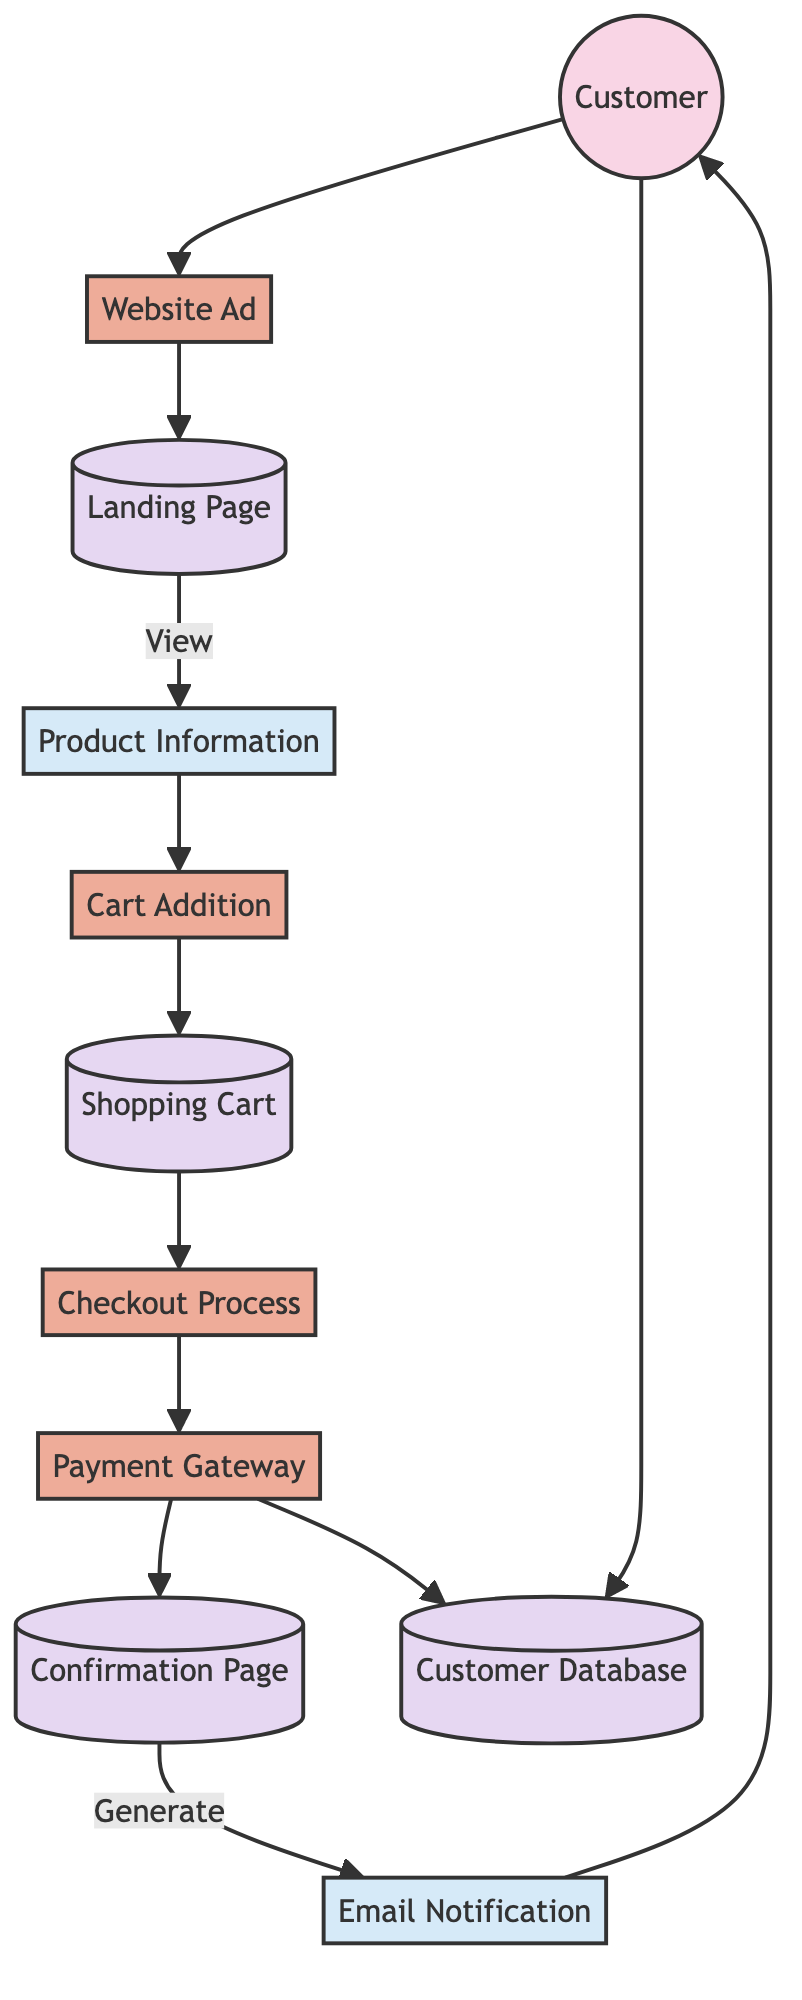What is the first interaction a customer has in the purchase funnel? The first interaction is through the Website Ad, where customers are attracted to the website.
Answer: Website Ad How many processes are represented in the diagram? The diagram includes four processes: Website Ad, Cart Addition, Checkout Process, and Payment Gateway. Counting these gives a total of four processes.
Answer: 4 What type of node is the Landing Page? The Landing Page acts as a data store, where customer information is kept after they click on an ad and land on the website.
Answer: data store Which data flow is generated after the customer completes the checkout process? After the Checkout Process is completed, an Email Notification is generated to confirm the order and provide the customer with order details.
Answer: Email Notification What action does a customer take after viewing Product Information? The next step after viewing Product Information is to engage in the Cart Addition process, where the customer adds the product to their shopping cart.
Answer: Cart Addition What is the purpose of the Payment Gateway in the diagram? The Payment Gateway processes the customer's payment information, enabling the customer to finalize their purchase.
Answer: processes payment What data store is used to confirm the customer's purchase? The Confirmation Page is the data store where the details of the order confirmation are displayed to the customer after the purchase is finalized.
Answer: Confirmation Page Which entity is last to interact with the customer? After all processes, the Email Notification is the final entity that interacts with the customer, providing them with confirmation details of their order.
Answer: Email Notification Where does the customer's information and purchase history get stored? The Customer Database is where all customer information and purchase history are maintained for future reference.
Answer: Customer Database How many data flows are shown in the diagram? There are two data flows indicated in the diagram: Product Information and Email Notification.
Answer: 2 